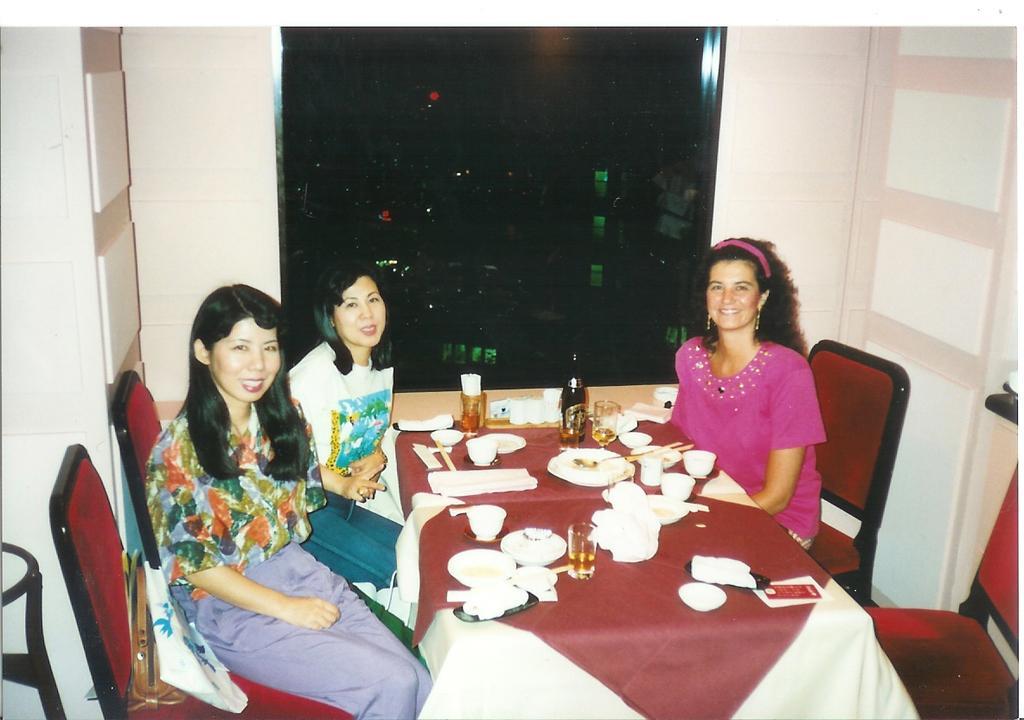Describe this image in one or two sentences. This picture is clicked in a restaurant. In the middle there is a table on that there is a glass, bottle, plant, tissues and some other items. On the right there is a woman she wear pink dress she is smiling her hair is short. On the left there are two women they are smiling they are sitting on the chairs. In the background there is a wall poster and wall. 